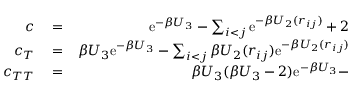Convert formula to latex. <formula><loc_0><loc_0><loc_500><loc_500>\begin{array} { r l r } { c } & = } & { e ^ { - \beta U _ { 3 } } - \sum _ { i < j } e ^ { - \beta U _ { 2 } ( r _ { i j } ) } + 2 } \\ { c _ { T } } & = } & { \beta U _ { 3 } e ^ { - \beta U _ { 3 } } - \sum _ { i < j } \beta U _ { 2 } ( r _ { i j } ) e ^ { - \beta U _ { 2 } ( r _ { i j } ) } } \\ { c _ { T T } } & = } & { \beta U _ { 3 } ( \beta U _ { 3 } - 2 ) e ^ { - \beta U _ { 3 } } - } \end{array}</formula> 